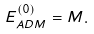<formula> <loc_0><loc_0><loc_500><loc_500>E ^ { ( 0 ) } _ { A D M } = M .</formula> 